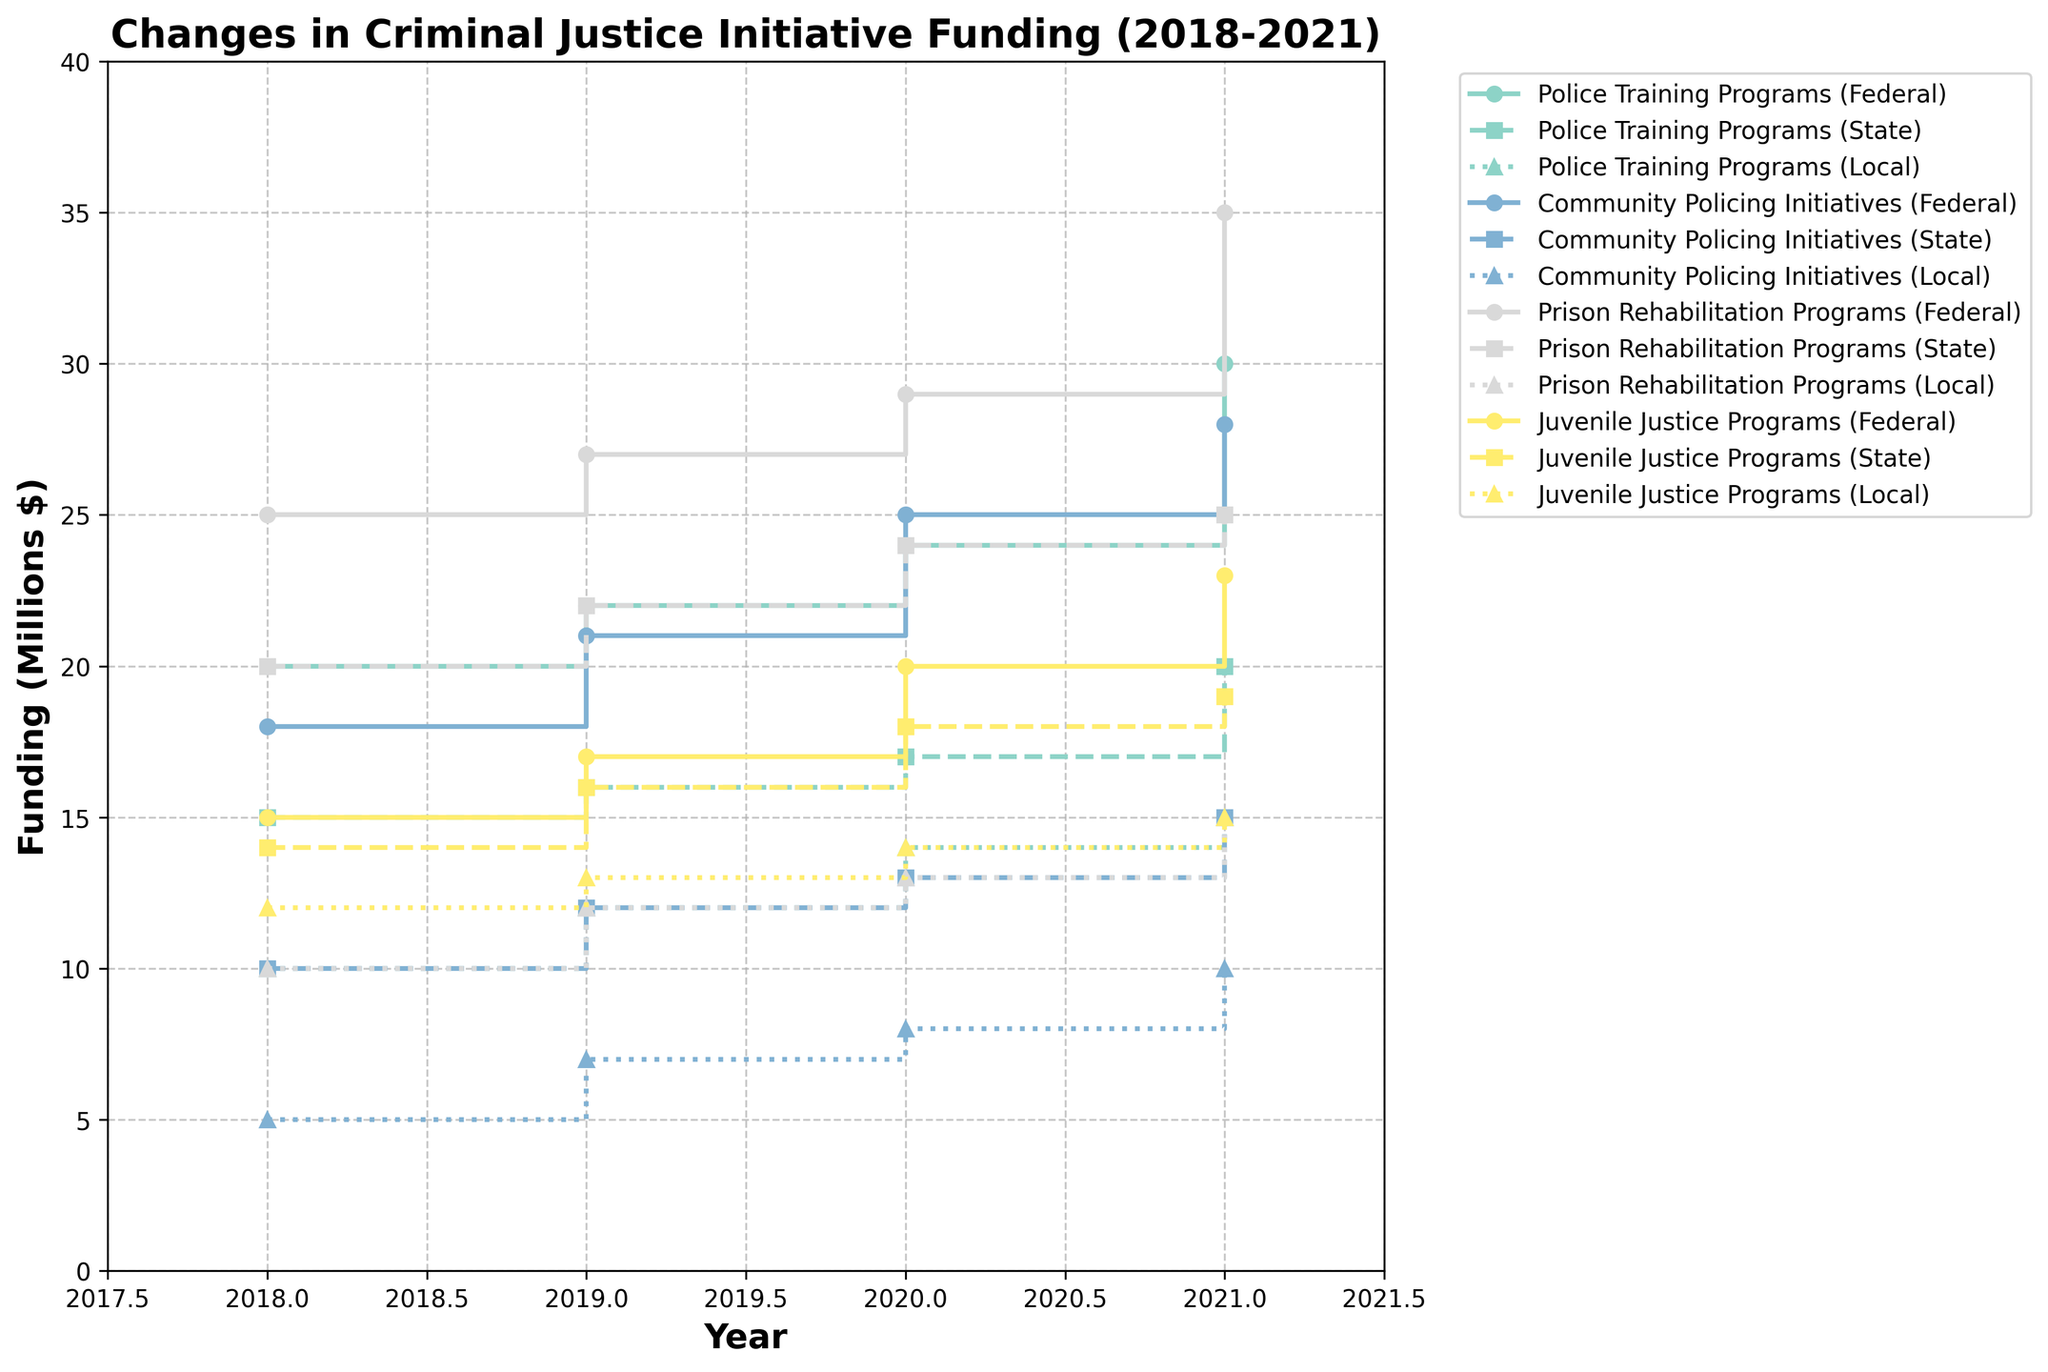Which criminal justice initiative saw the highest Federal funding in 2021? Compare the marker heights for Federal funding (solid lines) across different initiatives for the year 2021, and identify the highest one.
Answer: Prison Rehabilitation Programs How did Federal funding for Community Policing Initiatives change from 2018 to 2021? Look at the step markers for Community Policing Initiatives on the Federal funding line. Note the values at 2018 and 2021 and calculate the difference. $18M in 2018 increased to $28M in 2021, an increase of $10M.
Answer: Increased by $10M Which initiative received the least Local funding in 2018? Check the dotted lines (Local funding) for the year 2018 and find the lowest point among the initiatives. Community Policing Initiatives received $5M, which is the lowest.
Answer: Community Policing Initiatives What is the total funding for Juvenile Justice Programs across Federal, State, and Local levels in 2020? Sum the values for Federal, State, and Local funding for Juvenile Justice Programs in 2020. $20M (Federal) + $18M (State) + $14M (Local) = $52M
Answer: $52M Between 2018 and 2021, did any initiative have a year where State funding decreased compared to the previous year? Examine the dashed lines for each initiative across the years and check for any downward steps. No initiative saw a decrease in State funding within the specified period.
Answer: No Which initiative had the most consistent increase in Federal funding from 2018 to 2021? Check the solid lines for each initiative for consistent upward trends with evenly spaced increments. Police Training Programs had a steady increase from $20M in 2018 to $30M in 2021.
Answer: Police Training Programs Are there any initiatives where Local funding exceeded $14M at any point? Look at the highest points of the dotted lines for each initiative. For Juvenile Justice Programs, Local funding exceeds $14M in 2021.
Answer: Yes, Juvenile Justice Programs in 2021 Which initiative shows the largest absolute increase in State funding from 2018 to 2021? Calculate the difference in State funding for each initiative from 2018 to 2021 and identify the largest increase. Police Training Programs increased from $15M in 2018 to $20M in 2021, which is a $5M increase.
Answer: Police Training Programs During which year did Prison Rehabilitation Programs receive the highest combined funding from all levels? Sum the values for Federal, State, and Local funding for each year for Prison Rehabilitation Programs, and compare to find the year with the highest total. 2021 has the highest combined funding: $35M (Federal) + $25M (State) + $15M (Local) = $75M
Answer: 2021 